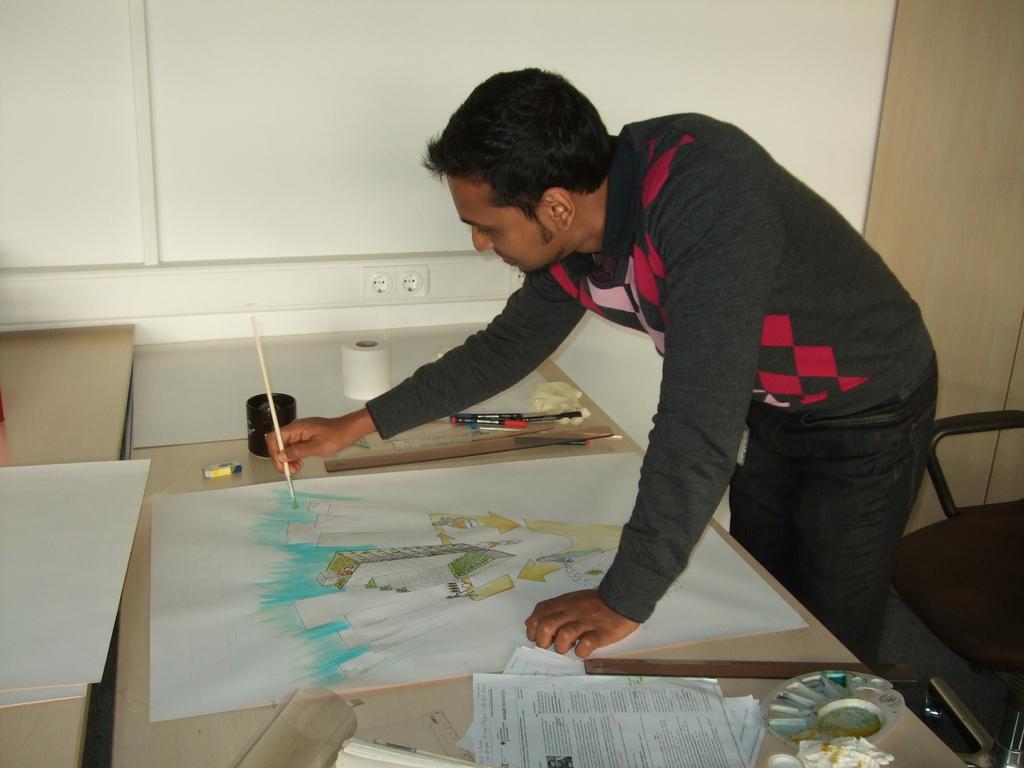Can you describe this image briefly? In this image i can see a person drawing a painting on the paper ,the paper is kept on the table and there are some objects kept on the table ,on the right side there is a chair. 